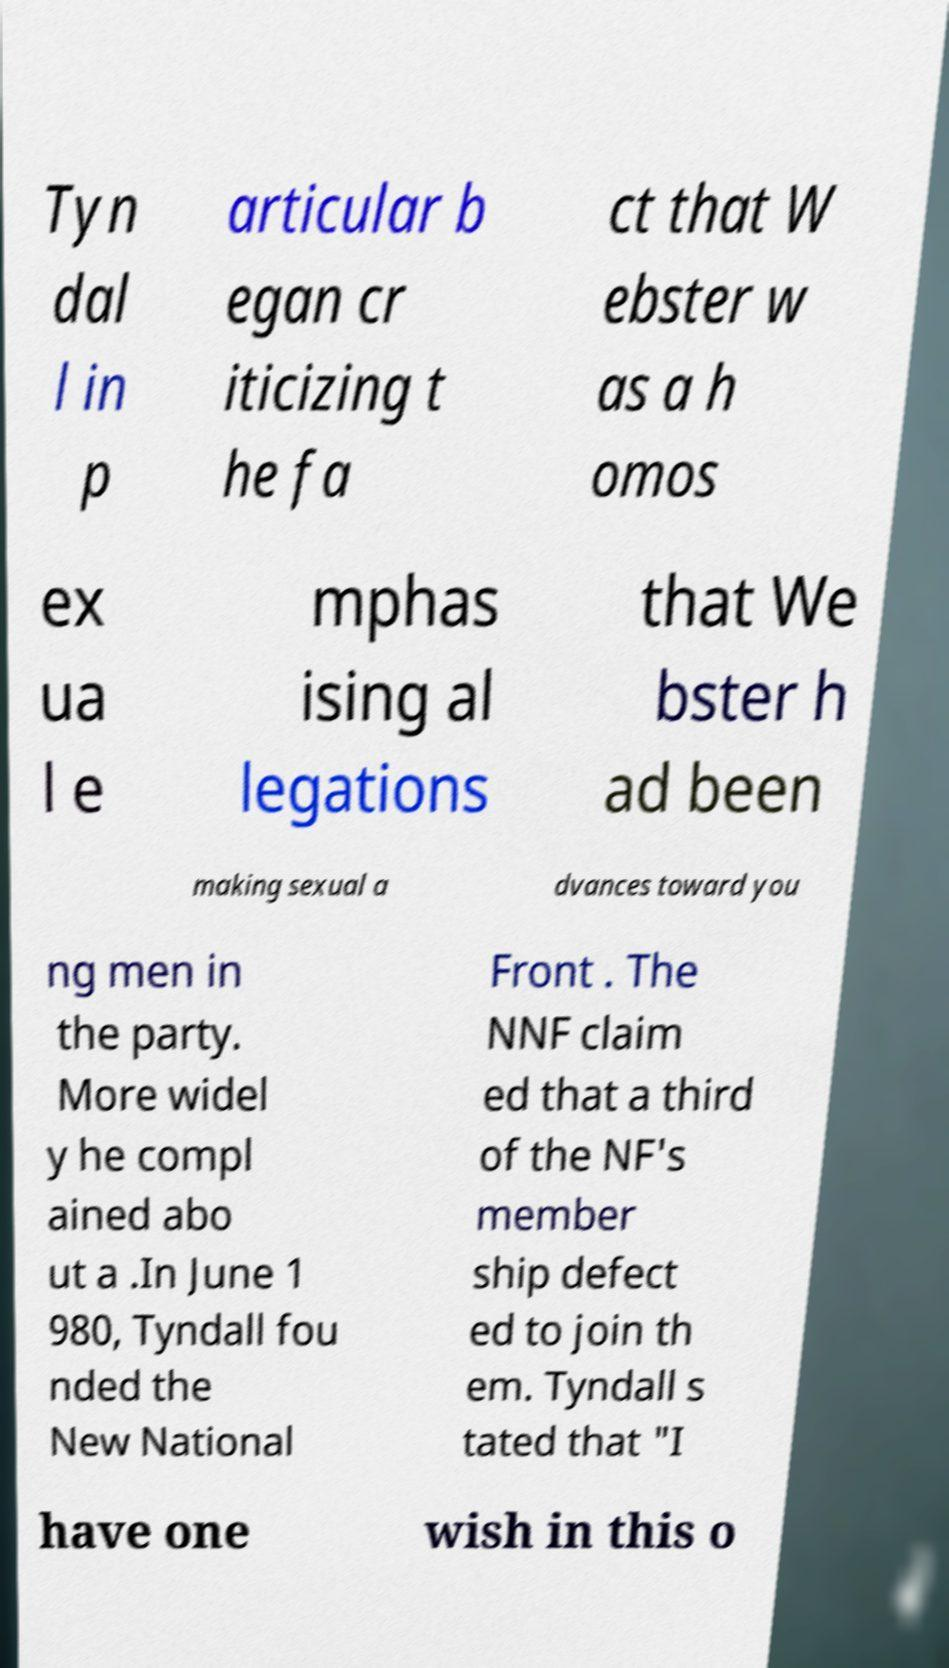Please read and relay the text visible in this image. What does it say? Tyn dal l in p articular b egan cr iticizing t he fa ct that W ebster w as a h omos ex ua l e mphas ising al legations that We bster h ad been making sexual a dvances toward you ng men in the party. More widel y he compl ained abo ut a .In June 1 980, Tyndall fou nded the New National Front . The NNF claim ed that a third of the NF's member ship defect ed to join th em. Tyndall s tated that "I have one wish in this o 